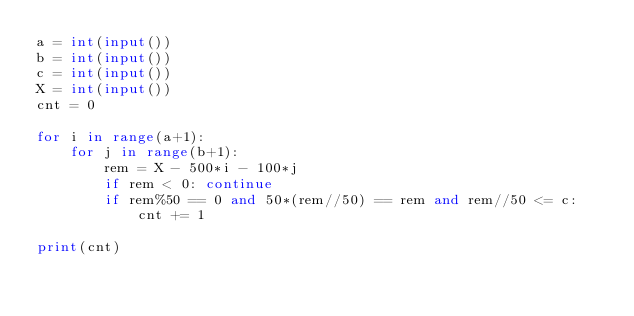Convert code to text. <code><loc_0><loc_0><loc_500><loc_500><_Python_>a = int(input())
b = int(input())
c = int(input())
X = int(input())
cnt = 0

for i in range(a+1):
    for j in range(b+1):
        rem = X - 500*i - 100*j
        if rem < 0: continue
        if rem%50 == 0 and 50*(rem//50) == rem and rem//50 <= c:
            cnt += 1

print(cnt)</code> 